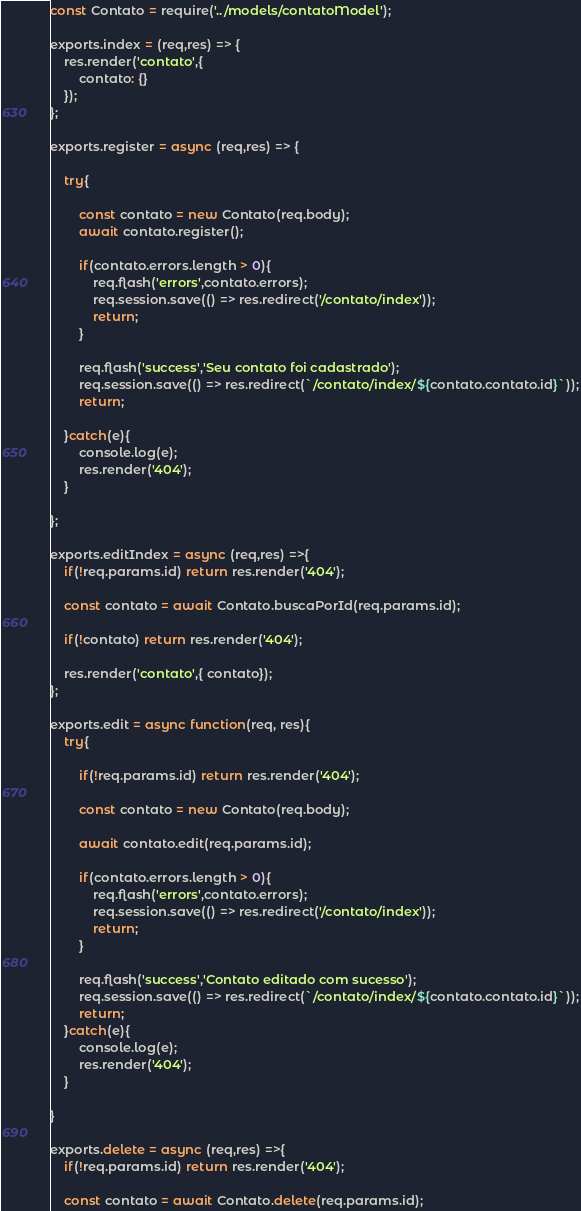<code> <loc_0><loc_0><loc_500><loc_500><_JavaScript_>const Contato = require('../models/contatoModel');

exports.index = (req,res) => {
    res.render('contato',{
        contato: {}
    });
};

exports.register = async (req,res) => {

    try{

        const contato = new Contato(req.body);
        await contato.register();
        
        if(contato.errors.length > 0){
            req.flash('errors',contato.errors);
            req.session.save(() => res.redirect('/contato/index'));
            return;
        }

        req.flash('success','Seu contato foi cadastrado');
        req.session.save(() => res.redirect(`/contato/index/${contato.contato.id}`));
        return;

    }catch(e){
        console.log(e);
        res.render('404');
    }

};

exports.editIndex = async (req,res) =>{
    if(!req.params.id) return res.render('404');
    
    const contato = await Contato.buscaPorId(req.params.id);

    if(!contato) return res.render('404');

    res.render('contato',{ contato});
};

exports.edit = async function(req, res){
    try{

        if(!req.params.id) return res.render('404');

        const contato = new Contato(req.body);

        await contato.edit(req.params.id);

        if(contato.errors.length > 0){
            req.flash('errors',contato.errors);
            req.session.save(() => res.redirect('/contato/index'));
            return;
        }

        req.flash('success','Contato editado com sucesso');
        req.session.save(() => res.redirect(`/contato/index/${contato.contato.id}`));
        return;
    }catch(e){
        console.log(e);
        res.render('404');
    }
    
}

exports.delete = async (req,res) =>{
    if(!req.params.id) return res.render('404');
    
    const contato = await Contato.delete(req.params.id);
</code> 